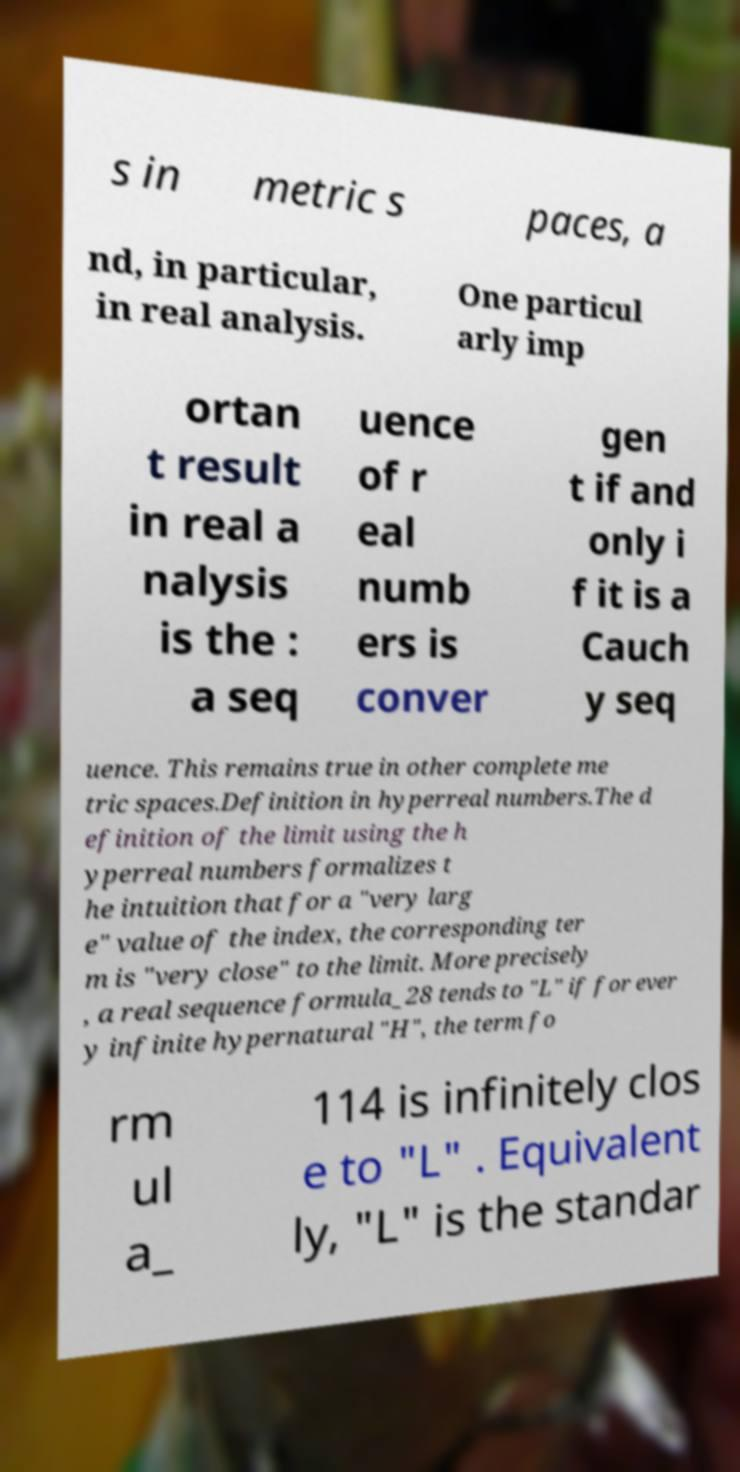Could you assist in decoding the text presented in this image and type it out clearly? s in metric s paces, a nd, in particular, in real analysis. One particul arly imp ortan t result in real a nalysis is the : a seq uence of r eal numb ers is conver gen t if and only i f it is a Cauch y seq uence. This remains true in other complete me tric spaces.Definition in hyperreal numbers.The d efinition of the limit using the h yperreal numbers formalizes t he intuition that for a "very larg e" value of the index, the corresponding ter m is "very close" to the limit. More precisely , a real sequence formula_28 tends to "L" if for ever y infinite hypernatural "H", the term fo rm ul a_ 114 is infinitely clos e to "L" . Equivalent ly, "L" is the standar 